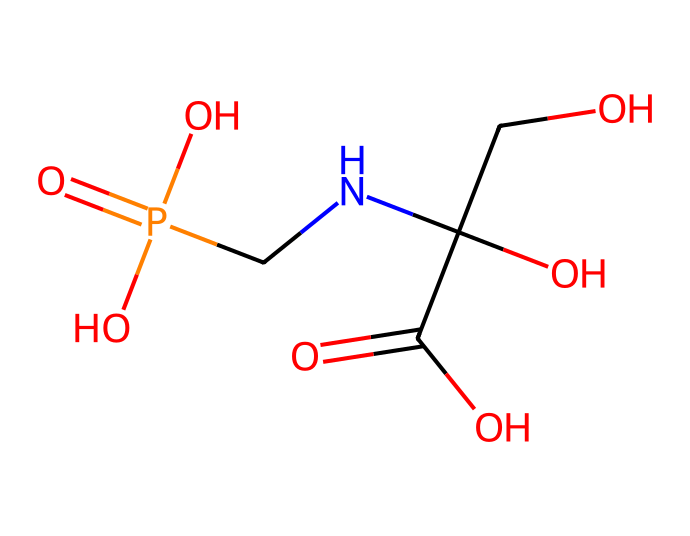What is the total number of atoms in glyphosate? By analyzing the provided SMILES representation, we can count each type of atom: 3 Carbon (C), 4 Oxygen (O), 1 Nitrogen (N), and 1 Phosphorus (P), leading to a total of 9 atoms when summed together.
Answer: 9 How many oxygen atoms are present in glyphosate? By examining the SMILES structure, we can clearly identify four occurrences of oxygen atoms, indicated by the letter 'O' throughout the formula.
Answer: 4 What is the functional group represented in glyphosate? The molecule contains a carboxylic acid group characterized by the –C(=O)O structure, which is identified by the part "C(=O)O" in the SMILES representation.
Answer: carboxylic acid Does glyphosate contain any nitrogen atoms? The presence of the letter 'N' in the SMILES string indicates that there is indeed one nitrogen atom in the glyphosate structure.
Answer: yes What type of phosphorus compound is glyphosate classified as? Given that glyphosate contains a phosphorus atom bonded to an oxygen with functional groups, it is generally classified as an organophosphorus compound.
Answer: organophosphorus What is the valency of the phosphorus atom in glyphosate? The phosphorus atom in glyphosate appears to have five valence electrons based on the structure and is typically tetrahedral in its compound arrangement; it forms bonds with oxygen and nitrogen.
Answer: 5 How many chiral centers are present in glyphosate? By examining the structure, we can see that there are two carbon atoms that have four different substituents, indicating the presence of two chiral centers.
Answer: 2 